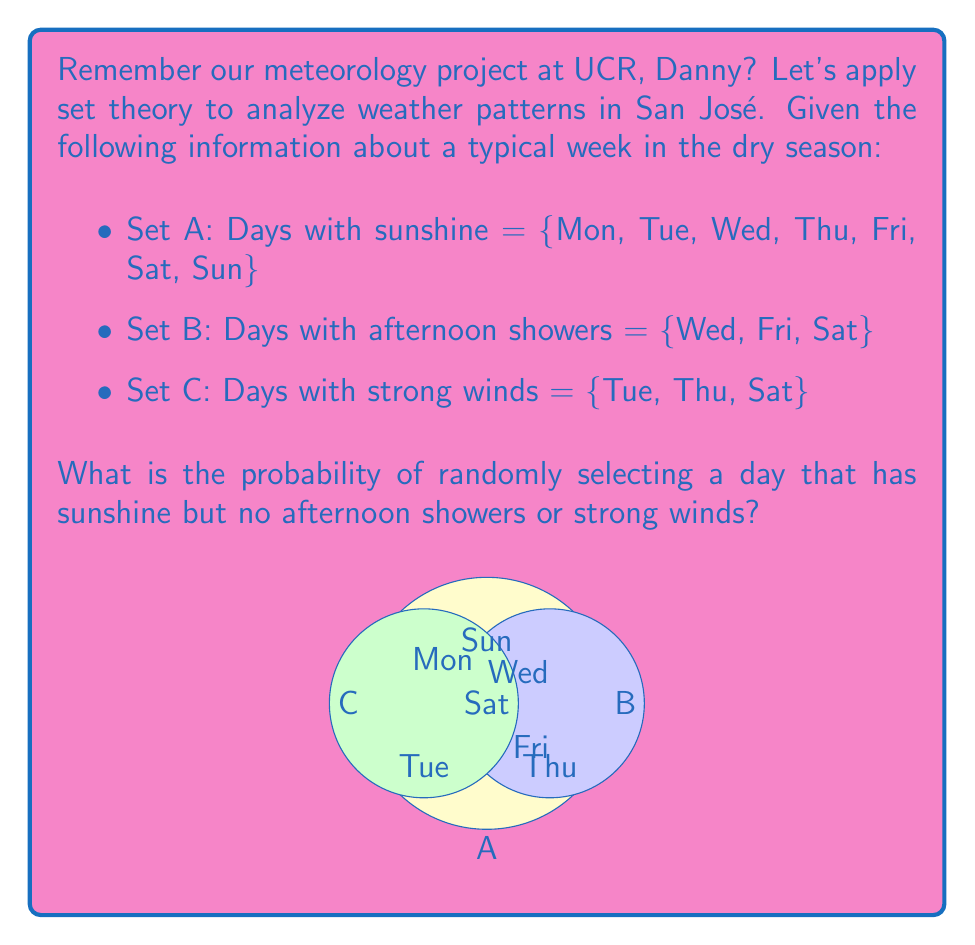Provide a solution to this math problem. Let's approach this step-by-step using set theory:

1) First, we need to find the days that have sunshine but no afternoon showers or strong winds. This can be represented as:

   $A \cap (B \cup C)^c$

   Where $(B \cup C)^c$ is the complement of $(B \cup C)$, i.e., days without afternoon showers or strong winds.

2) Let's find $B \cup C$:
   $B \cup C = \{Wed, Fri, Sat, Tue, Thu\}$

3) Now, $(B \cup C)^c$:
   $(B \cup C)^c = \{Mon, Sun\}$

4) Finally, $A \cap (B \cup C)^c$:
   $A \cap (B \cup C)^c = \{Mon, Sun\}$

5) To calculate the probability, we use:

   $P(event) = \frac{|favorable\;outcomes|}{|total\;possible\;outcomes|}$

   Where $|x|$ denotes the cardinality (number of elements) of set $x$.

6) In this case:
   $P(A \cap (B \cup C)^c) = \frac{|\{Mon, Sun\}|}{|\{Mon, Tue, Wed, Thu, Fri, Sat, Sun\}|} = \frac{2}{7}$

Therefore, the probability of randomly selecting a day with sunshine but no afternoon showers or strong winds is $\frac{2}{7}$.
Answer: $\frac{2}{7}$ 